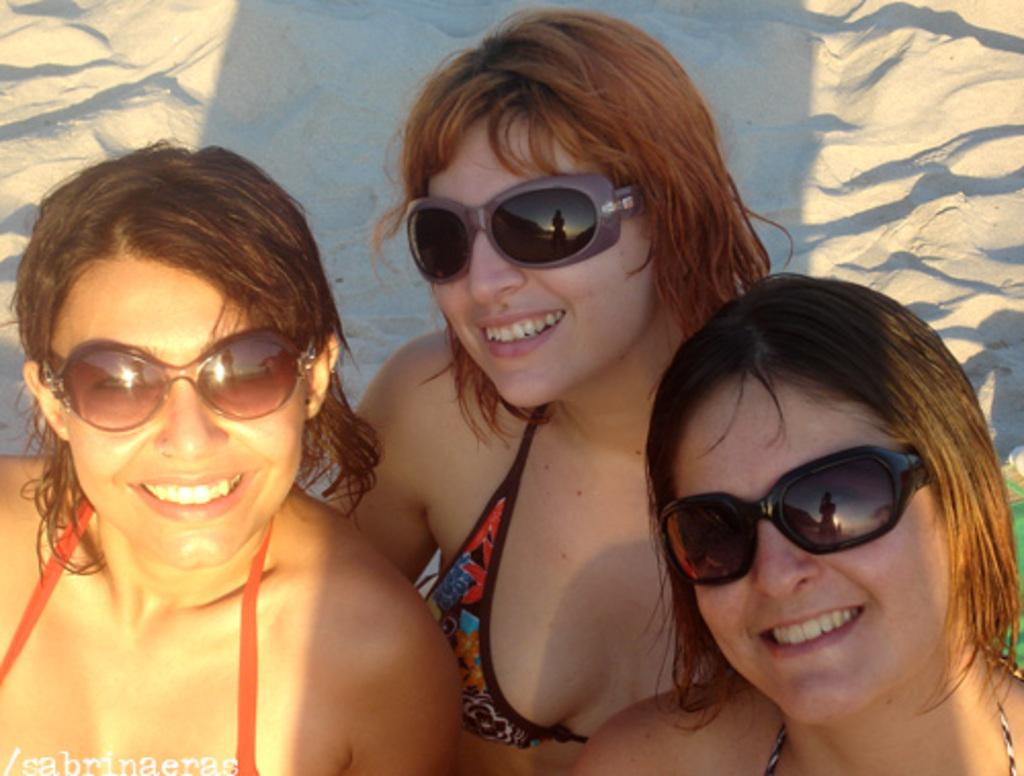What can be seen in the image? There are women standing in the image. Where are the women standing? The women are standing on the ground. What is the ground made of? There is sand on the ground. What are the women wearing on their faces? The women are wearing sunglasses. What direction are the women facing in the image? The provided facts do not mention the direction the women are facing, so it cannot be determined from the image. What type of spoon can be seen in the image? There is no spoon present in the image. 